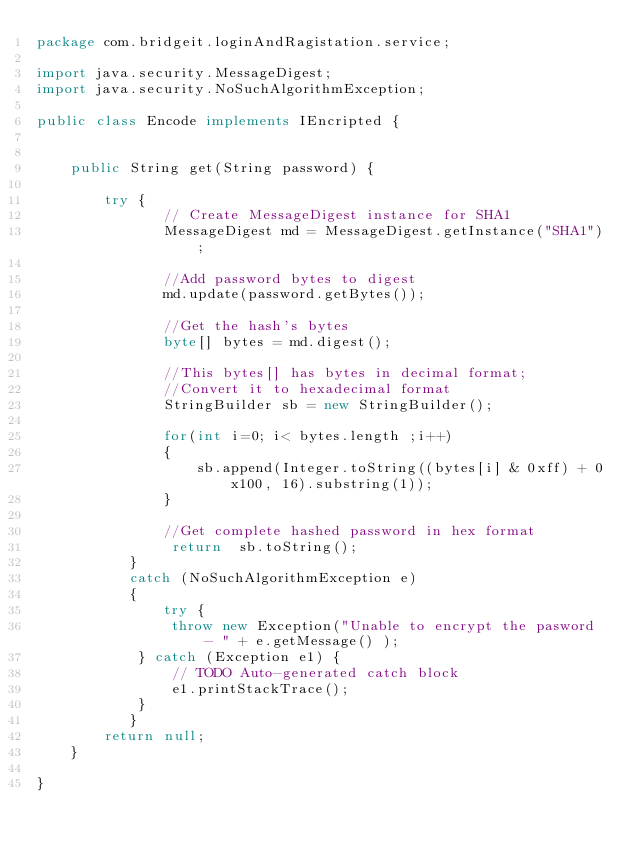Convert code to text. <code><loc_0><loc_0><loc_500><loc_500><_Java_>package com.bridgeit.loginAndRagistation.service;

import java.security.MessageDigest;
import java.security.NoSuchAlgorithmException;

public class Encode implements IEncripted {

	
	public String get(String password) {

		try {
	           // Create MessageDigest instance for SHA1
	           MessageDigest md = MessageDigest.getInstance("SHA1");
	           
	           //Add password bytes to digest
	           md.update(password.getBytes());
	           
	           //Get the hash's bytes 
	           byte[] bytes = md.digest();
	           
	           //This bytes[] has bytes in decimal format;
	           //Convert it to hexadecimal format
	           StringBuilder sb = new StringBuilder();
	           
	           for(int i=0; i< bytes.length ;i++)
	           {
	               sb.append(Integer.toString((bytes[i] & 0xff) + 0x100, 16).substring(1));
	           }
	           
	           //Get complete hashed password in hex format
	            return  sb.toString();
	       } 
	       catch (NoSuchAlgorithmException e) 
	       {
	           try {
				throw new Exception("Unable to encrypt the pasword - " + e.getMessage() );
			} catch (Exception e1) {
				// TODO Auto-generated catch block
				e1.printStackTrace();
			}
	       }
		return null;
	}

}
</code> 